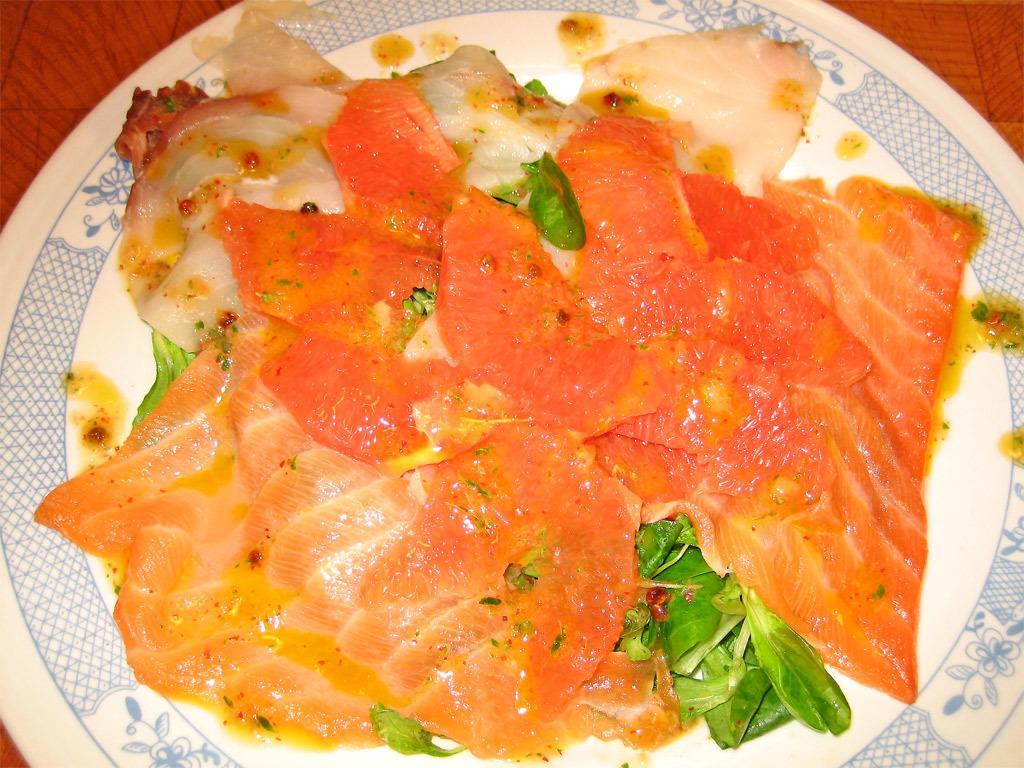Could you give a brief overview of what you see in this image? In the image in the center,we can see one table. On the table,we can see one plate and some food items. 